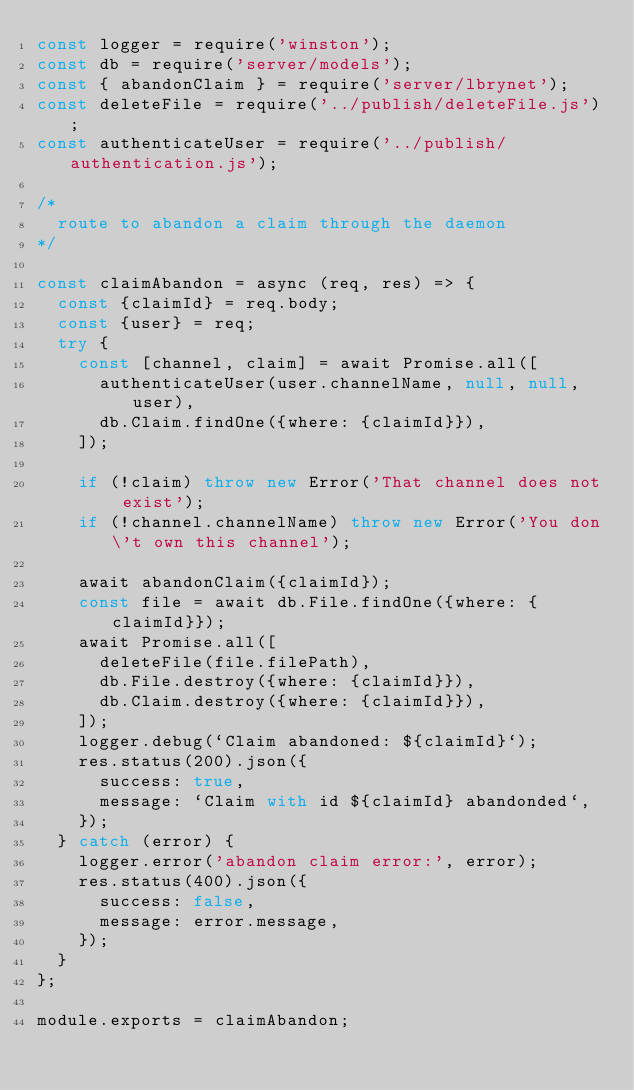Convert code to text. <code><loc_0><loc_0><loc_500><loc_500><_JavaScript_>const logger = require('winston');
const db = require('server/models');
const { abandonClaim } = require('server/lbrynet');
const deleteFile = require('../publish/deleteFile.js');
const authenticateUser = require('../publish/authentication.js');

/*
  route to abandon a claim through the daemon
*/

const claimAbandon = async (req, res) => {
  const {claimId} = req.body;
  const {user} = req;
  try {
    const [channel, claim] = await Promise.all([
      authenticateUser(user.channelName, null, null, user),
      db.Claim.findOne({where: {claimId}}),
    ]);

    if (!claim) throw new Error('That channel does not exist');
    if (!channel.channelName) throw new Error('You don\'t own this channel');

    await abandonClaim({claimId});
    const file = await db.File.findOne({where: {claimId}});
    await Promise.all([
      deleteFile(file.filePath),
      db.File.destroy({where: {claimId}}),
      db.Claim.destroy({where: {claimId}}),
    ]);
    logger.debug(`Claim abandoned: ${claimId}`);
    res.status(200).json({
      success: true,
      message: `Claim with id ${claimId} abandonded`,
    });
  } catch (error) {
    logger.error('abandon claim error:', error);
    res.status(400).json({
      success: false,
      message: error.message,
    });
  }
};

module.exports = claimAbandon;
</code> 